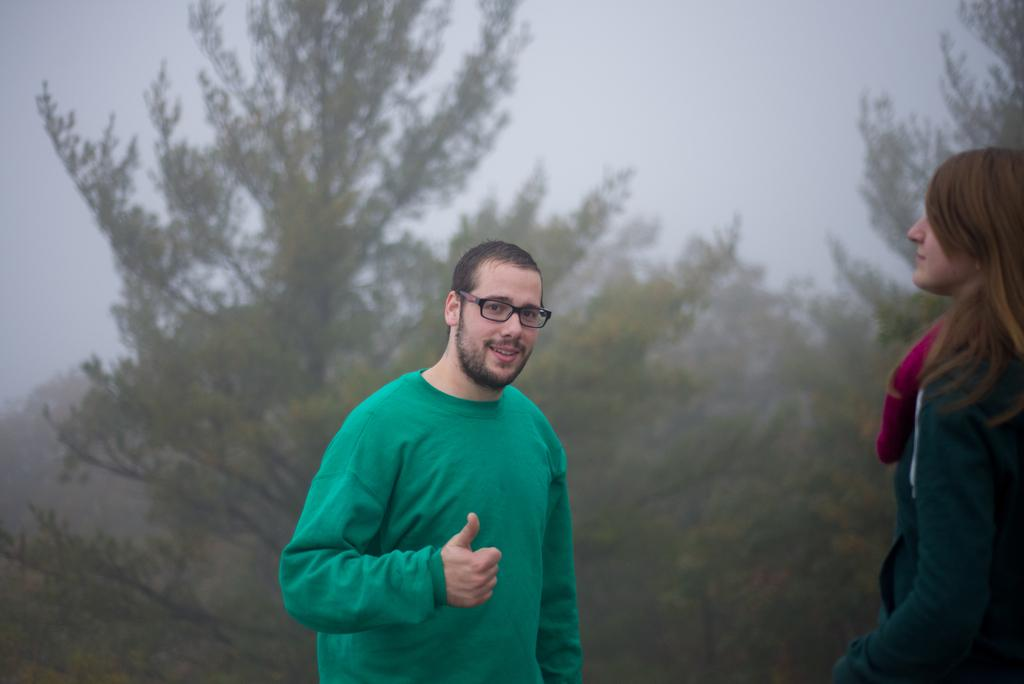What is the main subject in the middle of the image? There is a man standing in the middle of the image. What is the man doing in the image? The man is smiling in the image. What can be seen in the background behind the man? There are trees visible behind the man. Who else is present in the image? There is a woman standing in the bottom right side of the image. What is the weather condition in the image? There is fog visible at the top of the image. What type of cake is being served on the hill in the image? There is no cake or hill present in the image. What is the man's source of pleasure in the image? The image does not provide information about the man's source of pleasure. 